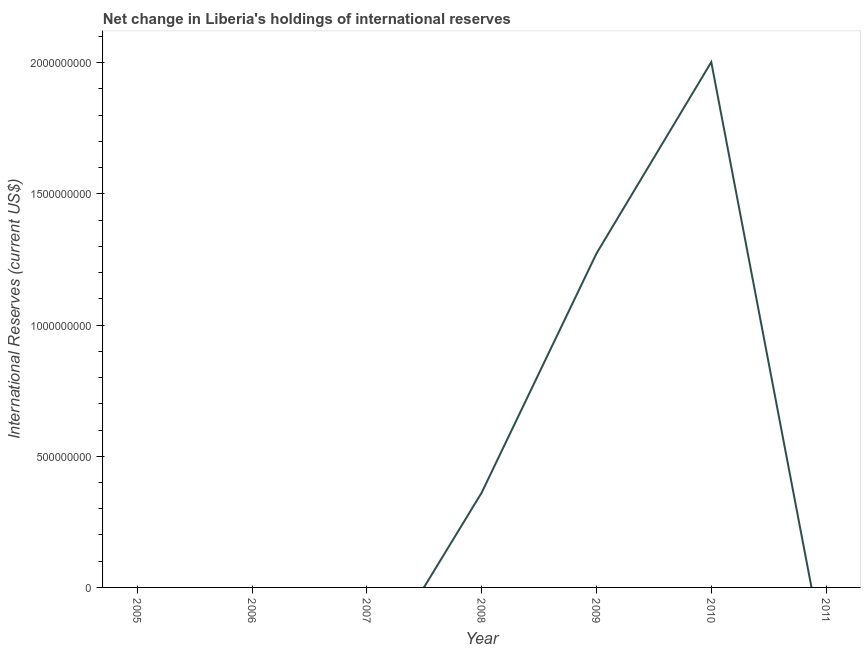Across all years, what is the maximum reserves and related items?
Offer a terse response. 2.00e+09. Across all years, what is the minimum reserves and related items?
Your answer should be compact. 0. What is the sum of the reserves and related items?
Offer a terse response. 3.64e+09. What is the average reserves and related items per year?
Your answer should be compact. 5.20e+08. In how many years, is the reserves and related items greater than 200000000 US$?
Your answer should be very brief. 3. Is the difference between the reserves and related items in 2008 and 2009 greater than the difference between any two years?
Offer a very short reply. No. What is the difference between the highest and the second highest reserves and related items?
Give a very brief answer. 7.30e+08. Is the sum of the reserves and related items in 2009 and 2010 greater than the maximum reserves and related items across all years?
Provide a short and direct response. Yes. What is the difference between the highest and the lowest reserves and related items?
Your answer should be very brief. 2.00e+09. Does the reserves and related items monotonically increase over the years?
Your answer should be very brief. No. How many years are there in the graph?
Provide a succinct answer. 7. Does the graph contain any zero values?
Your answer should be very brief. Yes. Does the graph contain grids?
Your response must be concise. No. What is the title of the graph?
Provide a succinct answer. Net change in Liberia's holdings of international reserves. What is the label or title of the X-axis?
Provide a short and direct response. Year. What is the label or title of the Y-axis?
Provide a succinct answer. International Reserves (current US$). What is the International Reserves (current US$) of 2005?
Offer a very short reply. 0. What is the International Reserves (current US$) of 2008?
Provide a short and direct response. 3.61e+08. What is the International Reserves (current US$) in 2009?
Offer a very short reply. 1.27e+09. What is the International Reserves (current US$) in 2010?
Your answer should be compact. 2.00e+09. What is the difference between the International Reserves (current US$) in 2008 and 2009?
Offer a very short reply. -9.12e+08. What is the difference between the International Reserves (current US$) in 2008 and 2010?
Make the answer very short. -1.64e+09. What is the difference between the International Reserves (current US$) in 2009 and 2010?
Give a very brief answer. -7.30e+08. What is the ratio of the International Reserves (current US$) in 2008 to that in 2009?
Give a very brief answer. 0.28. What is the ratio of the International Reserves (current US$) in 2008 to that in 2010?
Keep it short and to the point. 0.18. What is the ratio of the International Reserves (current US$) in 2009 to that in 2010?
Your answer should be compact. 0.64. 